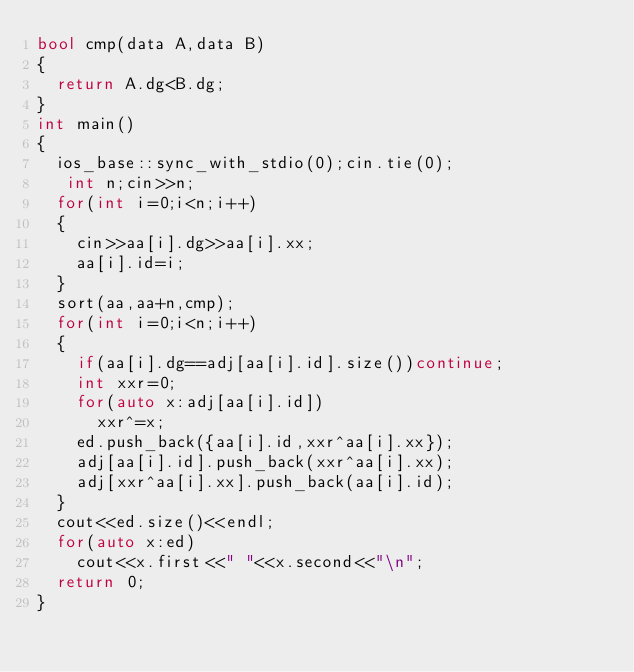<code> <loc_0><loc_0><loc_500><loc_500><_C++_>bool cmp(data A,data B)
{
  return A.dg<B.dg;
}
int main()
{
  ios_base::sync_with_stdio(0);cin.tie(0);
   int n;cin>>n;
  for(int i=0;i<n;i++)
  {
    cin>>aa[i].dg>>aa[i].xx;
    aa[i].id=i;
  }
  sort(aa,aa+n,cmp);
  for(int i=0;i<n;i++)
  {
    if(aa[i].dg==adj[aa[i].id].size())continue;
    int xxr=0;
    for(auto x:adj[aa[i].id])
      xxr^=x;
    ed.push_back({aa[i].id,xxr^aa[i].xx});
    adj[aa[i].id].push_back(xxr^aa[i].xx);
    adj[xxr^aa[i].xx].push_back(aa[i].id);
  }
  cout<<ed.size()<<endl;
  for(auto x:ed)
    cout<<x.first<<" "<<x.second<<"\n";
  return 0;
}</code> 